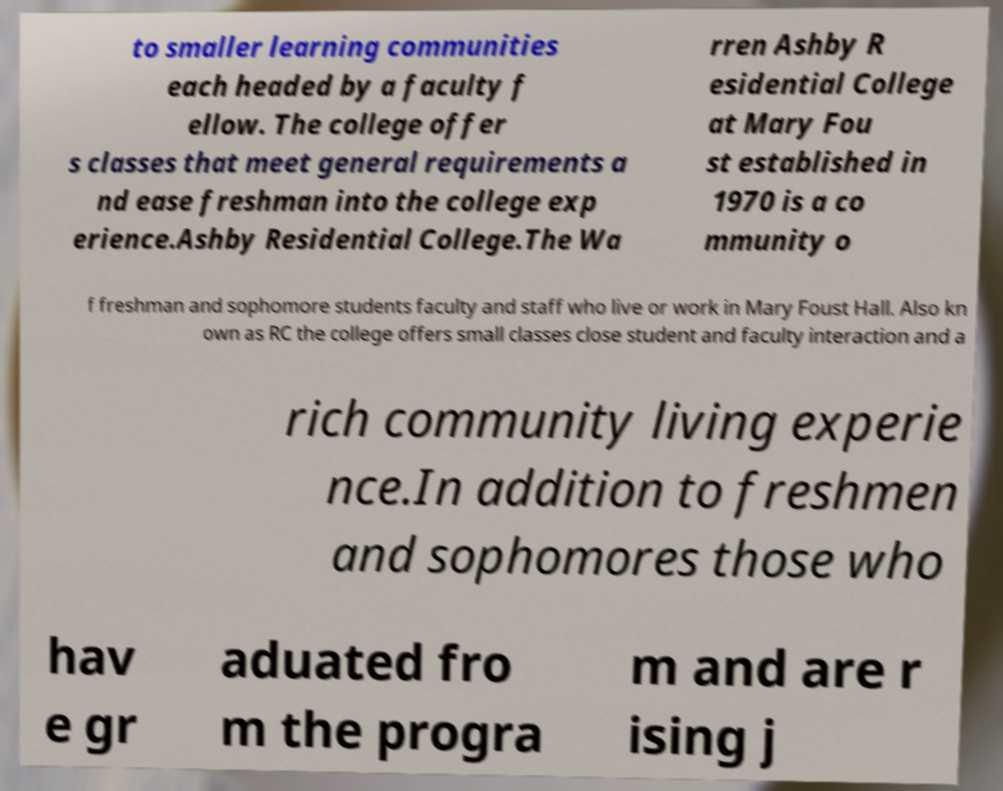Could you assist in decoding the text presented in this image and type it out clearly? to smaller learning communities each headed by a faculty f ellow. The college offer s classes that meet general requirements a nd ease freshman into the college exp erience.Ashby Residential College.The Wa rren Ashby R esidential College at Mary Fou st established in 1970 is a co mmunity o f freshman and sophomore students faculty and staff who live or work in Mary Foust Hall. Also kn own as RC the college offers small classes close student and faculty interaction and a rich community living experie nce.In addition to freshmen and sophomores those who hav e gr aduated fro m the progra m and are r ising j 